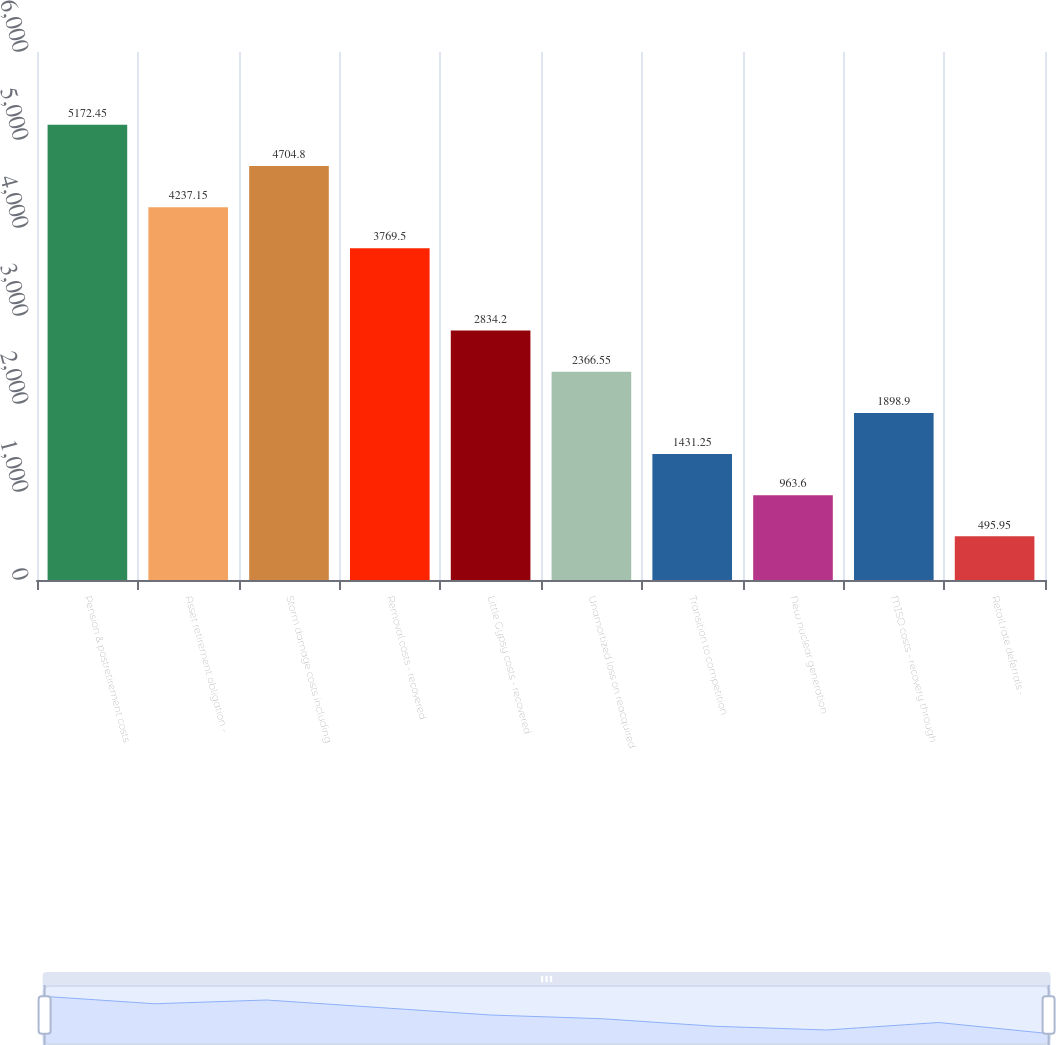Convert chart to OTSL. <chart><loc_0><loc_0><loc_500><loc_500><bar_chart><fcel>Pension & postretirement costs<fcel>Asset retirement obligation -<fcel>Storm damage costs including<fcel>Removal costs - recovered<fcel>Little Gypsy costs - recovered<fcel>Unamortized loss on reacquired<fcel>Transition to competition<fcel>New nuclear generation<fcel>MISO costs - recovery through<fcel>Retail rate deferrals -<nl><fcel>5172.45<fcel>4237.15<fcel>4704.8<fcel>3769.5<fcel>2834.2<fcel>2366.55<fcel>1431.25<fcel>963.6<fcel>1898.9<fcel>495.95<nl></chart> 